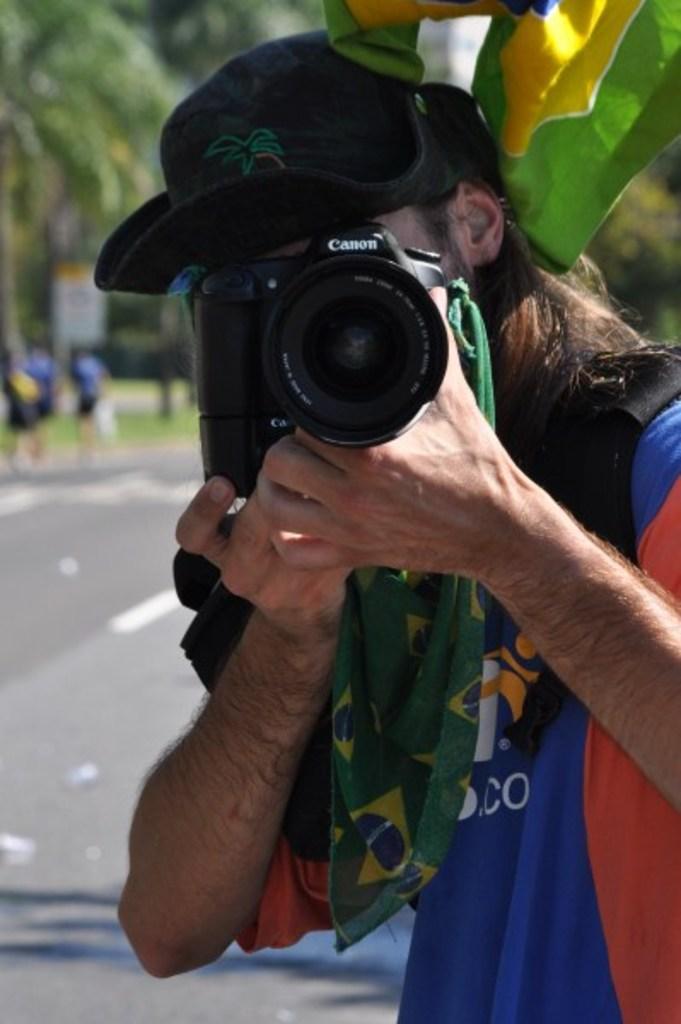In one or two sentences, can you explain what this image depicts? This image consists of a person who is clicking pictures. That person has a camera in his hand. There are trees on the top left corner. There are persons walking in the left side. 